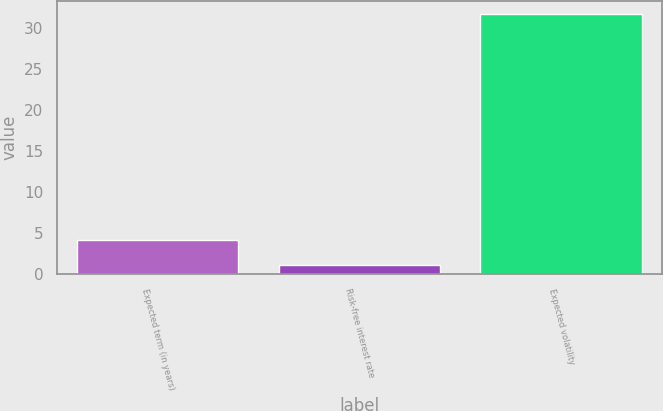Convert chart. <chart><loc_0><loc_0><loc_500><loc_500><bar_chart><fcel>Expected term (in years)<fcel>Risk-free interest rate<fcel>Expected volatility<nl><fcel>4.16<fcel>1.1<fcel>31.7<nl></chart> 